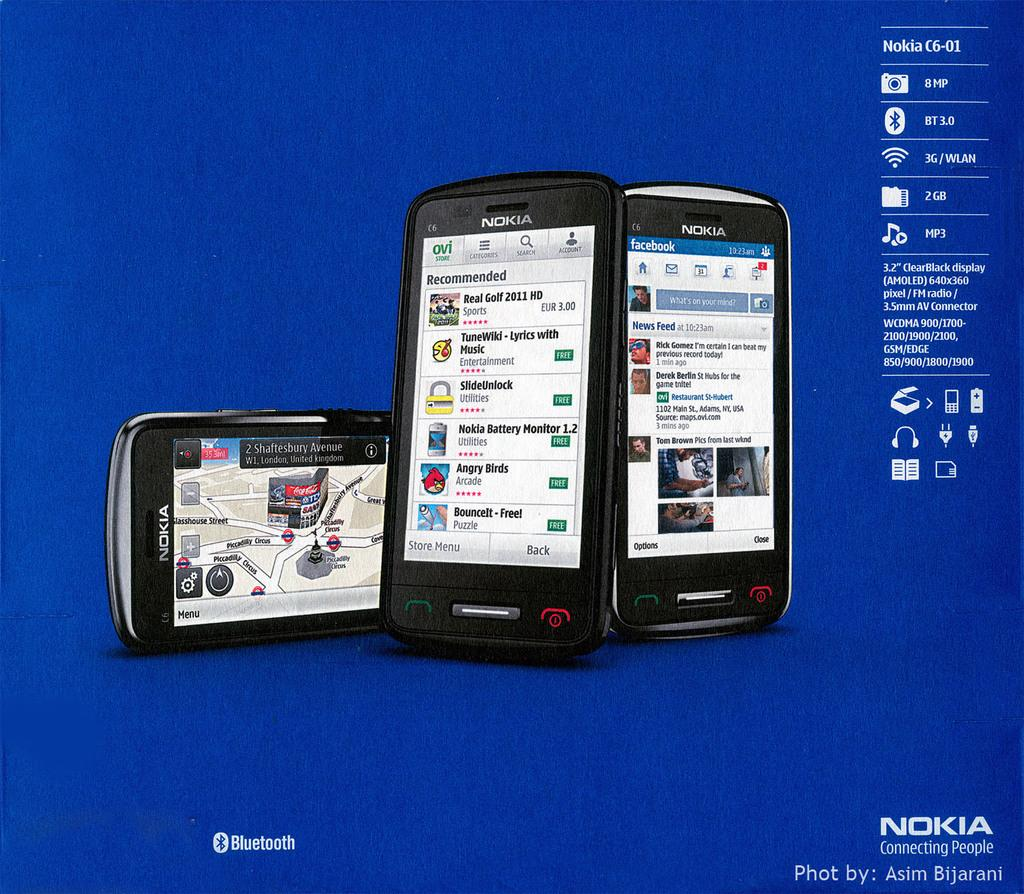<image>
Relay a brief, clear account of the picture shown. three Nokia cell phones photoed by Asim Bijarani 